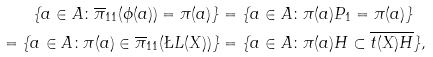<formula> <loc_0><loc_0><loc_500><loc_500>\{ a \in A \colon \overline { \pi } _ { 1 1 } ( \phi ( a ) ) = \pi ( a ) \} & = \{ a \in A \colon \pi ( a ) P _ { 1 } = \pi ( a ) \} \\ = \{ a \in A \colon \pi ( a ) \in \overline { \pi } _ { 1 1 } ( \L L ( X ) ) \} & = \{ a \in A \colon \pi ( a ) H \subset \overline { t ( X ) H } \} ,</formula> 